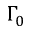<formula> <loc_0><loc_0><loc_500><loc_500>\Gamma _ { 0 }</formula> 